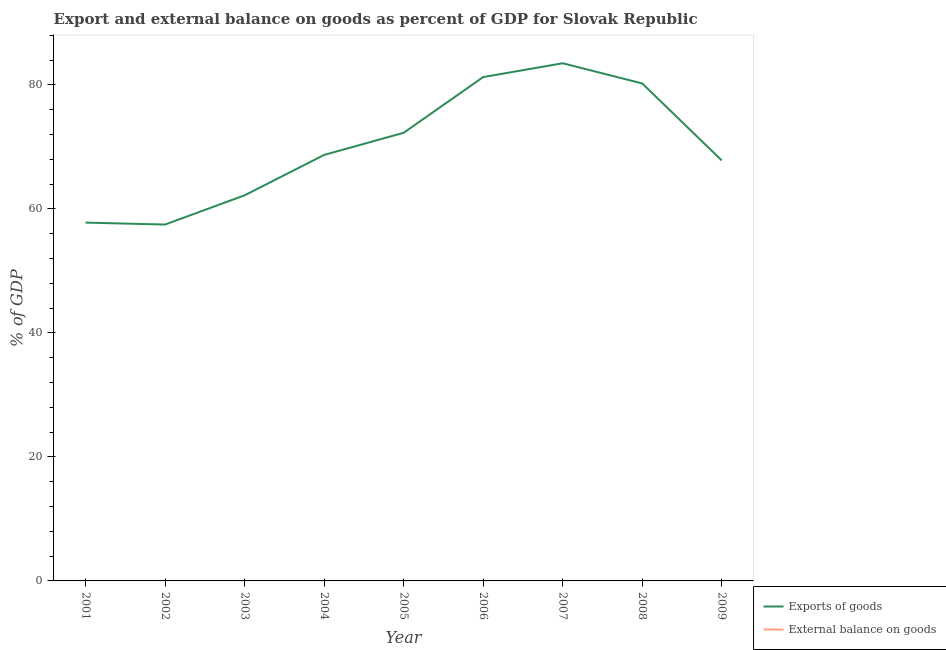What is the export of goods as percentage of gdp in 2005?
Provide a succinct answer. 72.28. Across all years, what is the maximum export of goods as percentage of gdp?
Offer a very short reply. 83.5. Across all years, what is the minimum export of goods as percentage of gdp?
Offer a very short reply. 57.48. In which year was the export of goods as percentage of gdp maximum?
Provide a short and direct response. 2007. What is the total external balance on goods as percentage of gdp in the graph?
Provide a succinct answer. 0. What is the difference between the export of goods as percentage of gdp in 2004 and that in 2006?
Ensure brevity in your answer.  -12.55. What is the difference between the export of goods as percentage of gdp in 2006 and the external balance on goods as percentage of gdp in 2001?
Offer a very short reply. 81.27. What is the average external balance on goods as percentage of gdp per year?
Provide a succinct answer. 0. What is the ratio of the export of goods as percentage of gdp in 2001 to that in 2009?
Ensure brevity in your answer.  0.85. What is the difference between the highest and the second highest export of goods as percentage of gdp?
Your answer should be compact. 2.23. What is the difference between the highest and the lowest export of goods as percentage of gdp?
Make the answer very short. 26.02. In how many years, is the external balance on goods as percentage of gdp greater than the average external balance on goods as percentage of gdp taken over all years?
Your answer should be compact. 0. Is the sum of the export of goods as percentage of gdp in 2003 and 2009 greater than the maximum external balance on goods as percentage of gdp across all years?
Provide a short and direct response. Yes. Does the external balance on goods as percentage of gdp monotonically increase over the years?
Offer a very short reply. No. Is the export of goods as percentage of gdp strictly less than the external balance on goods as percentage of gdp over the years?
Keep it short and to the point. No. How many years are there in the graph?
Provide a short and direct response. 9. What is the difference between two consecutive major ticks on the Y-axis?
Give a very brief answer. 20. Are the values on the major ticks of Y-axis written in scientific E-notation?
Make the answer very short. No. Does the graph contain grids?
Keep it short and to the point. No. How many legend labels are there?
Provide a short and direct response. 2. How are the legend labels stacked?
Provide a short and direct response. Vertical. What is the title of the graph?
Your response must be concise. Export and external balance on goods as percent of GDP for Slovak Republic. What is the label or title of the Y-axis?
Offer a very short reply. % of GDP. What is the % of GDP in Exports of goods in 2001?
Your answer should be very brief. 57.79. What is the % of GDP of Exports of goods in 2002?
Your answer should be compact. 57.48. What is the % of GDP of Exports of goods in 2003?
Your answer should be very brief. 62.19. What is the % of GDP of External balance on goods in 2003?
Provide a succinct answer. 0. What is the % of GDP of Exports of goods in 2004?
Offer a very short reply. 68.71. What is the % of GDP in Exports of goods in 2005?
Your answer should be compact. 72.28. What is the % of GDP of External balance on goods in 2005?
Your answer should be very brief. 0. What is the % of GDP of Exports of goods in 2006?
Your answer should be very brief. 81.27. What is the % of GDP in External balance on goods in 2006?
Offer a terse response. 0. What is the % of GDP in Exports of goods in 2007?
Offer a very short reply. 83.5. What is the % of GDP in External balance on goods in 2007?
Ensure brevity in your answer.  0. What is the % of GDP in Exports of goods in 2008?
Offer a very short reply. 80.24. What is the % of GDP in Exports of goods in 2009?
Provide a short and direct response. 67.83. What is the % of GDP in External balance on goods in 2009?
Offer a very short reply. 0. Across all years, what is the maximum % of GDP of Exports of goods?
Ensure brevity in your answer.  83.5. Across all years, what is the minimum % of GDP in Exports of goods?
Your answer should be compact. 57.48. What is the total % of GDP in Exports of goods in the graph?
Your response must be concise. 631.3. What is the difference between the % of GDP of Exports of goods in 2001 and that in 2002?
Your response must be concise. 0.31. What is the difference between the % of GDP of Exports of goods in 2001 and that in 2003?
Offer a terse response. -4.4. What is the difference between the % of GDP of Exports of goods in 2001 and that in 2004?
Give a very brief answer. -10.92. What is the difference between the % of GDP of Exports of goods in 2001 and that in 2005?
Your answer should be very brief. -14.49. What is the difference between the % of GDP of Exports of goods in 2001 and that in 2006?
Make the answer very short. -23.47. What is the difference between the % of GDP of Exports of goods in 2001 and that in 2007?
Your answer should be compact. -25.71. What is the difference between the % of GDP of Exports of goods in 2001 and that in 2008?
Provide a short and direct response. -22.45. What is the difference between the % of GDP of Exports of goods in 2001 and that in 2009?
Give a very brief answer. -10.03. What is the difference between the % of GDP of Exports of goods in 2002 and that in 2003?
Keep it short and to the point. -4.71. What is the difference between the % of GDP of Exports of goods in 2002 and that in 2004?
Ensure brevity in your answer.  -11.23. What is the difference between the % of GDP of Exports of goods in 2002 and that in 2005?
Your response must be concise. -14.8. What is the difference between the % of GDP in Exports of goods in 2002 and that in 2006?
Your response must be concise. -23.78. What is the difference between the % of GDP of Exports of goods in 2002 and that in 2007?
Your answer should be compact. -26.02. What is the difference between the % of GDP in Exports of goods in 2002 and that in 2008?
Your answer should be very brief. -22.76. What is the difference between the % of GDP in Exports of goods in 2002 and that in 2009?
Provide a short and direct response. -10.34. What is the difference between the % of GDP of Exports of goods in 2003 and that in 2004?
Provide a short and direct response. -6.52. What is the difference between the % of GDP of Exports of goods in 2003 and that in 2005?
Provide a succinct answer. -10.09. What is the difference between the % of GDP of Exports of goods in 2003 and that in 2006?
Your answer should be very brief. -19.07. What is the difference between the % of GDP of Exports of goods in 2003 and that in 2007?
Your answer should be compact. -21.31. What is the difference between the % of GDP of Exports of goods in 2003 and that in 2008?
Provide a short and direct response. -18.05. What is the difference between the % of GDP of Exports of goods in 2003 and that in 2009?
Offer a terse response. -5.63. What is the difference between the % of GDP in Exports of goods in 2004 and that in 2005?
Give a very brief answer. -3.57. What is the difference between the % of GDP of Exports of goods in 2004 and that in 2006?
Keep it short and to the point. -12.55. What is the difference between the % of GDP of Exports of goods in 2004 and that in 2007?
Your answer should be compact. -14.79. What is the difference between the % of GDP in Exports of goods in 2004 and that in 2008?
Ensure brevity in your answer.  -11.53. What is the difference between the % of GDP in Exports of goods in 2004 and that in 2009?
Make the answer very short. 0.89. What is the difference between the % of GDP in Exports of goods in 2005 and that in 2006?
Ensure brevity in your answer.  -8.98. What is the difference between the % of GDP of Exports of goods in 2005 and that in 2007?
Keep it short and to the point. -11.22. What is the difference between the % of GDP in Exports of goods in 2005 and that in 2008?
Your answer should be very brief. -7.96. What is the difference between the % of GDP of Exports of goods in 2005 and that in 2009?
Provide a succinct answer. 4.46. What is the difference between the % of GDP of Exports of goods in 2006 and that in 2007?
Your answer should be very brief. -2.23. What is the difference between the % of GDP of Exports of goods in 2006 and that in 2008?
Your response must be concise. 1.02. What is the difference between the % of GDP of Exports of goods in 2006 and that in 2009?
Make the answer very short. 13.44. What is the difference between the % of GDP of Exports of goods in 2007 and that in 2008?
Offer a terse response. 3.26. What is the difference between the % of GDP of Exports of goods in 2007 and that in 2009?
Give a very brief answer. 15.67. What is the difference between the % of GDP of Exports of goods in 2008 and that in 2009?
Your response must be concise. 12.42. What is the average % of GDP in Exports of goods per year?
Offer a very short reply. 70.14. What is the ratio of the % of GDP in Exports of goods in 2001 to that in 2002?
Offer a very short reply. 1.01. What is the ratio of the % of GDP in Exports of goods in 2001 to that in 2003?
Give a very brief answer. 0.93. What is the ratio of the % of GDP of Exports of goods in 2001 to that in 2004?
Your answer should be compact. 0.84. What is the ratio of the % of GDP of Exports of goods in 2001 to that in 2005?
Provide a short and direct response. 0.8. What is the ratio of the % of GDP of Exports of goods in 2001 to that in 2006?
Make the answer very short. 0.71. What is the ratio of the % of GDP of Exports of goods in 2001 to that in 2007?
Ensure brevity in your answer.  0.69. What is the ratio of the % of GDP in Exports of goods in 2001 to that in 2008?
Your response must be concise. 0.72. What is the ratio of the % of GDP of Exports of goods in 2001 to that in 2009?
Provide a short and direct response. 0.85. What is the ratio of the % of GDP in Exports of goods in 2002 to that in 2003?
Provide a short and direct response. 0.92. What is the ratio of the % of GDP of Exports of goods in 2002 to that in 2004?
Keep it short and to the point. 0.84. What is the ratio of the % of GDP in Exports of goods in 2002 to that in 2005?
Make the answer very short. 0.8. What is the ratio of the % of GDP of Exports of goods in 2002 to that in 2006?
Provide a succinct answer. 0.71. What is the ratio of the % of GDP of Exports of goods in 2002 to that in 2007?
Make the answer very short. 0.69. What is the ratio of the % of GDP of Exports of goods in 2002 to that in 2008?
Ensure brevity in your answer.  0.72. What is the ratio of the % of GDP in Exports of goods in 2002 to that in 2009?
Offer a terse response. 0.85. What is the ratio of the % of GDP in Exports of goods in 2003 to that in 2004?
Provide a short and direct response. 0.91. What is the ratio of the % of GDP of Exports of goods in 2003 to that in 2005?
Ensure brevity in your answer.  0.86. What is the ratio of the % of GDP of Exports of goods in 2003 to that in 2006?
Offer a terse response. 0.77. What is the ratio of the % of GDP of Exports of goods in 2003 to that in 2007?
Provide a short and direct response. 0.74. What is the ratio of the % of GDP in Exports of goods in 2003 to that in 2008?
Your answer should be very brief. 0.78. What is the ratio of the % of GDP of Exports of goods in 2003 to that in 2009?
Your response must be concise. 0.92. What is the ratio of the % of GDP of Exports of goods in 2004 to that in 2005?
Provide a succinct answer. 0.95. What is the ratio of the % of GDP of Exports of goods in 2004 to that in 2006?
Offer a very short reply. 0.85. What is the ratio of the % of GDP of Exports of goods in 2004 to that in 2007?
Your response must be concise. 0.82. What is the ratio of the % of GDP of Exports of goods in 2004 to that in 2008?
Provide a short and direct response. 0.86. What is the ratio of the % of GDP of Exports of goods in 2004 to that in 2009?
Offer a terse response. 1.01. What is the ratio of the % of GDP in Exports of goods in 2005 to that in 2006?
Provide a short and direct response. 0.89. What is the ratio of the % of GDP of Exports of goods in 2005 to that in 2007?
Keep it short and to the point. 0.87. What is the ratio of the % of GDP of Exports of goods in 2005 to that in 2008?
Ensure brevity in your answer.  0.9. What is the ratio of the % of GDP of Exports of goods in 2005 to that in 2009?
Your answer should be very brief. 1.07. What is the ratio of the % of GDP in Exports of goods in 2006 to that in 2007?
Provide a succinct answer. 0.97. What is the ratio of the % of GDP in Exports of goods in 2006 to that in 2008?
Give a very brief answer. 1.01. What is the ratio of the % of GDP in Exports of goods in 2006 to that in 2009?
Offer a terse response. 1.2. What is the ratio of the % of GDP of Exports of goods in 2007 to that in 2008?
Keep it short and to the point. 1.04. What is the ratio of the % of GDP of Exports of goods in 2007 to that in 2009?
Provide a succinct answer. 1.23. What is the ratio of the % of GDP of Exports of goods in 2008 to that in 2009?
Keep it short and to the point. 1.18. What is the difference between the highest and the second highest % of GDP in Exports of goods?
Your answer should be very brief. 2.23. What is the difference between the highest and the lowest % of GDP of Exports of goods?
Make the answer very short. 26.02. 